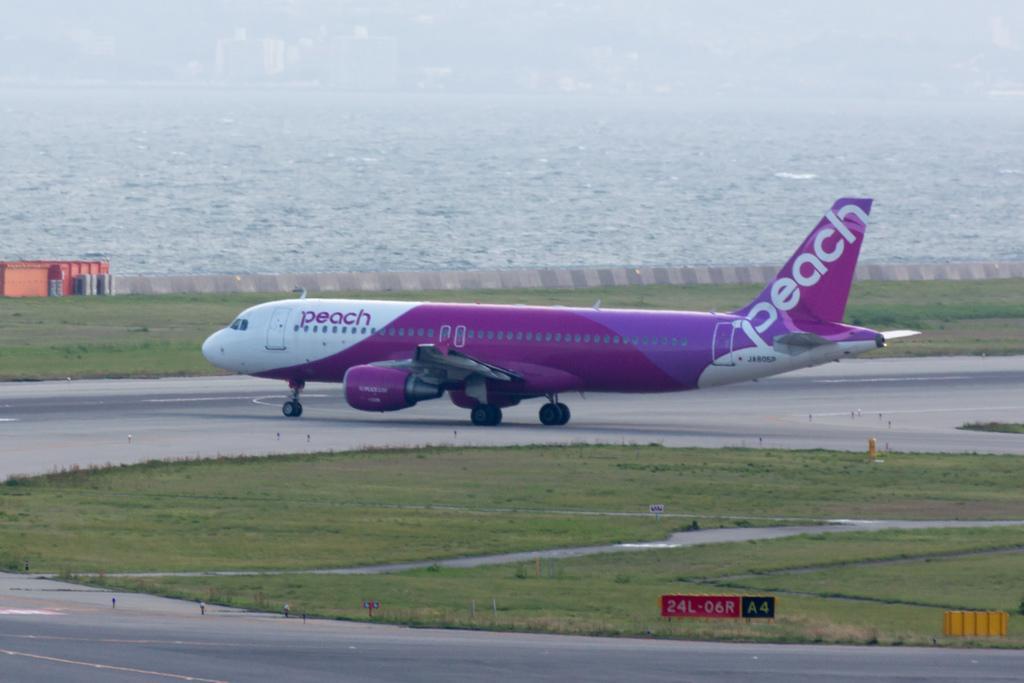Please provide a concise description of this image. In the center of the image, we can see an aeroplane and in the background, there is water and we can see a fence and a shed. At the bottom, there is ground and some boards, poles and there is road. 